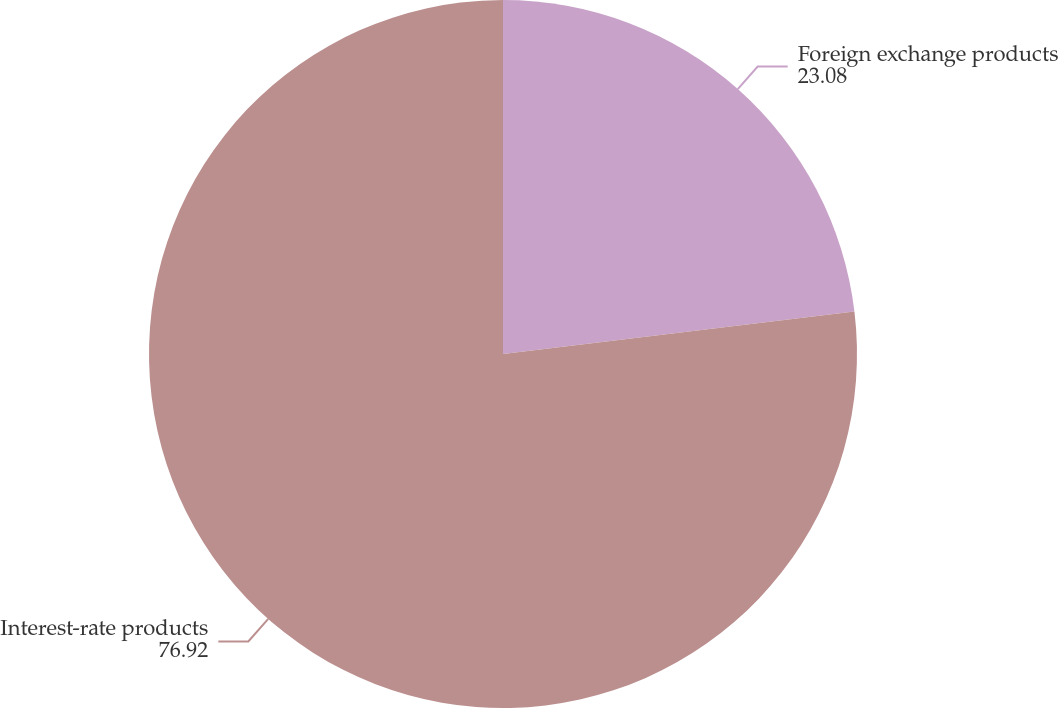<chart> <loc_0><loc_0><loc_500><loc_500><pie_chart><fcel>Foreign exchange products<fcel>Interest-rate products<nl><fcel>23.08%<fcel>76.92%<nl></chart> 